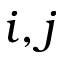Convert formula to latex. <formula><loc_0><loc_0><loc_500><loc_500>i , j</formula> 